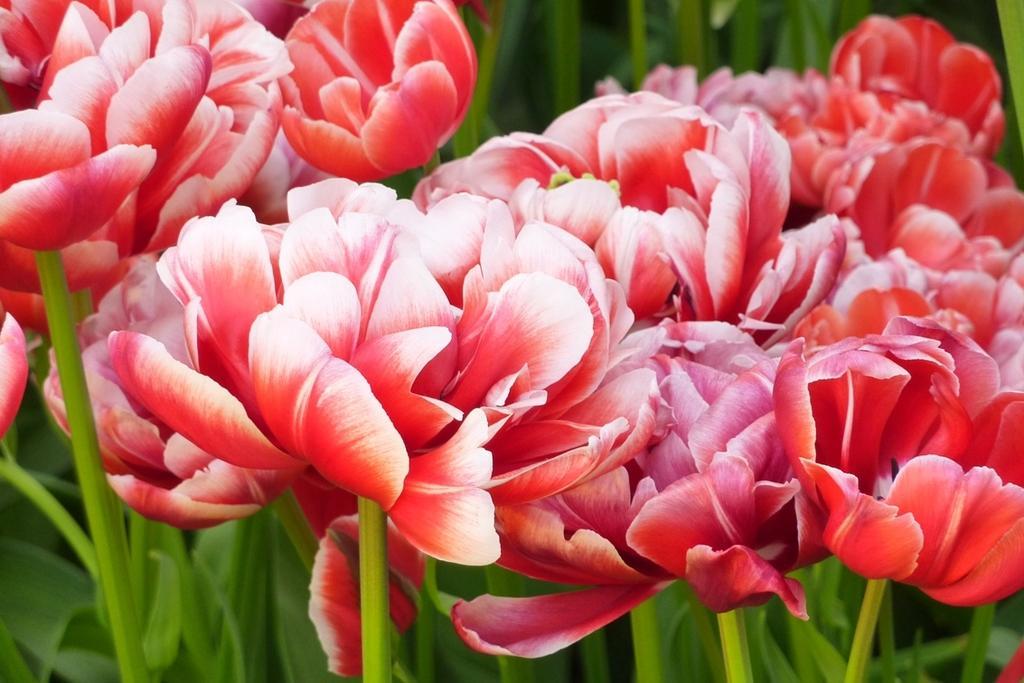How would you summarize this image in a sentence or two? In this picture I can see many flowers. Behind that I can see some plants. 